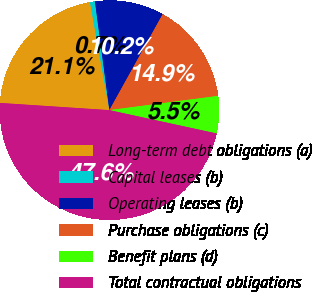<chart> <loc_0><loc_0><loc_500><loc_500><pie_chart><fcel>Long-term debt obligations (a)<fcel>Capital leases (b)<fcel>Operating leases (b)<fcel>Purchase obligations (c)<fcel>Benefit plans (d)<fcel>Total contractual obligations<nl><fcel>21.12%<fcel>0.73%<fcel>10.17%<fcel>14.86%<fcel>5.48%<fcel>47.63%<nl></chart> 